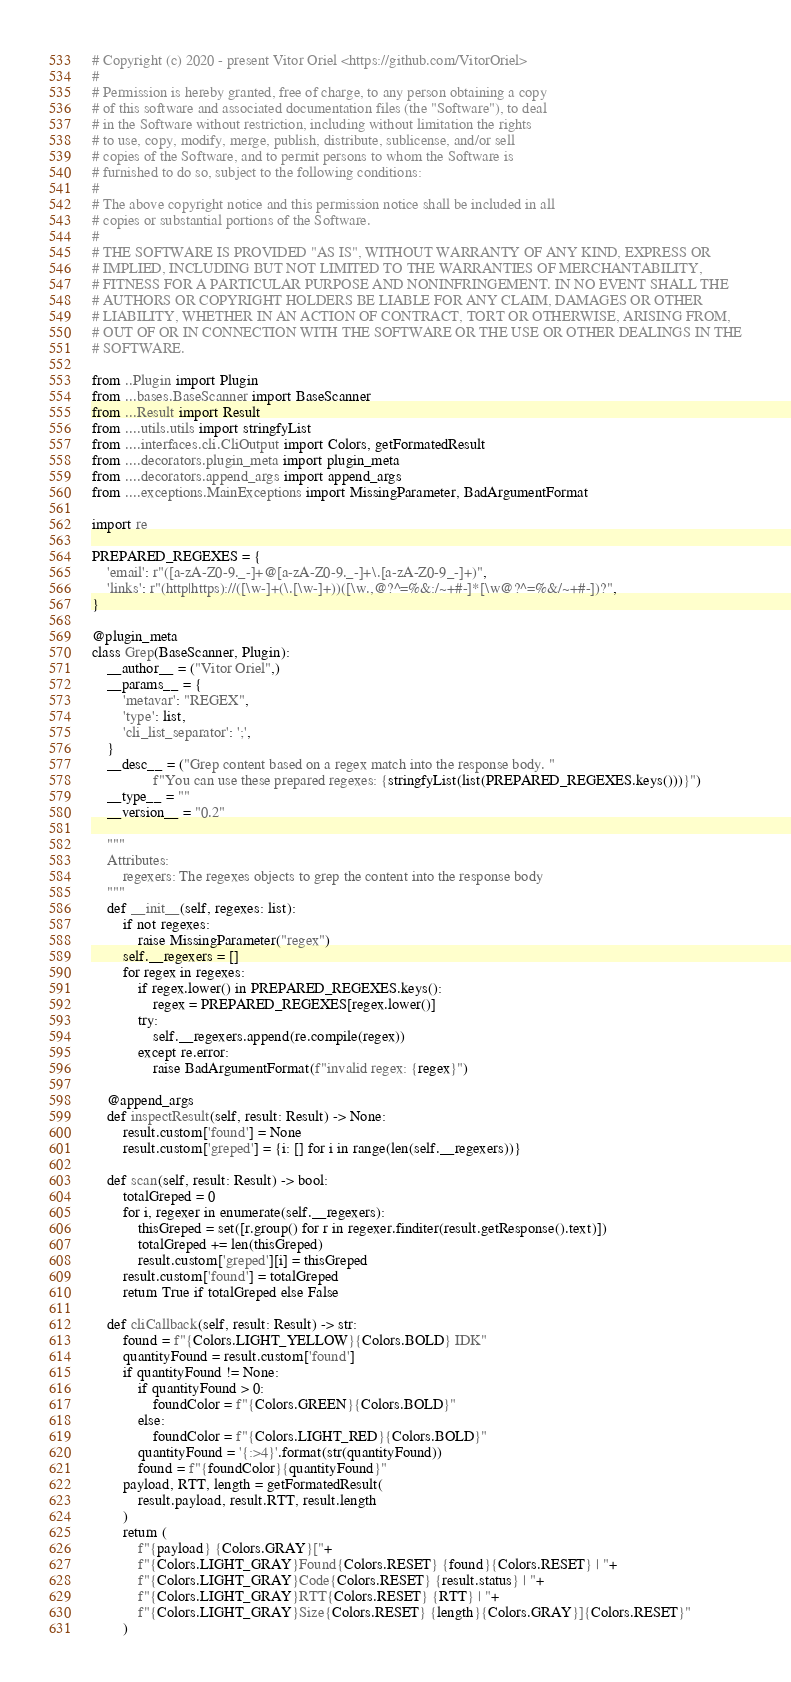<code> <loc_0><loc_0><loc_500><loc_500><_Python_># Copyright (c) 2020 - present Vitor Oriel <https://github.com/VitorOriel>
#
# Permission is hereby granted, free of charge, to any person obtaining a copy
# of this software and associated documentation files (the "Software"), to deal
# in the Software without restriction, including without limitation the rights
# to use, copy, modify, merge, publish, distribute, sublicense, and/or sell
# copies of the Software, and to permit persons to whom the Software is
# furnished to do so, subject to the following conditions:
#
# The above copyright notice and this permission notice shall be included in all
# copies or substantial portions of the Software.
#
# THE SOFTWARE IS PROVIDED "AS IS", WITHOUT WARRANTY OF ANY KIND, EXPRESS OR
# IMPLIED, INCLUDING BUT NOT LIMITED TO THE WARRANTIES OF MERCHANTABILITY,
# FITNESS FOR A PARTICULAR PURPOSE AND NONINFRINGEMENT. IN NO EVENT SHALL THE
# AUTHORS OR COPYRIGHT HOLDERS BE LIABLE FOR ANY CLAIM, DAMAGES OR OTHER
# LIABILITY, WHETHER IN AN ACTION OF CONTRACT, TORT OR OTHERWISE, ARISING FROM,
# OUT OF OR IN CONNECTION WITH THE SOFTWARE OR THE USE OR OTHER DEALINGS IN THE
# SOFTWARE.

from ..Plugin import Plugin
from ...bases.BaseScanner import BaseScanner
from ...Result import Result
from ....utils.utils import stringfyList
from ....interfaces.cli.CliOutput import Colors, getFormatedResult
from ....decorators.plugin_meta import plugin_meta
from ....decorators.append_args import append_args
from ....exceptions.MainExceptions import MissingParameter, BadArgumentFormat

import re

PREPARED_REGEXES = {
    'email': r"([a-zA-Z0-9._-]+@[a-zA-Z0-9._-]+\.[a-zA-Z0-9_-]+)",
    'links': r"(http|https)://([\w-]+(\.[\w-]+))([\w.,@?^=%&:/~+#-]*[\w@?^=%&/~+#-])?",
}

@plugin_meta
class Grep(BaseScanner, Plugin):
    __author__ = ("Vitor Oriel",)
    __params__ = {
        'metavar': "REGEX",
        'type': list,
        'cli_list_separator': ';',
    }
    __desc__ = ("Grep content based on a regex match into the response body. "
                f"You can use these prepared regexes: {stringfyList(list(PREPARED_REGEXES.keys()))}")
    __type__ = ""
    __version__ = "0.2"

    """
    Attributes:
        regexers: The regexes objects to grep the content into the response body
    """
    def __init__(self, regexes: list):
        if not regexes:
            raise MissingParameter("regex")
        self.__regexers = []
        for regex in regexes:
            if regex.lower() in PREPARED_REGEXES.keys():
                regex = PREPARED_REGEXES[regex.lower()]
            try:
                self.__regexers.append(re.compile(regex))
            except re.error:
                raise BadArgumentFormat(f"invalid regex: {regex}")

    @append_args
    def inspectResult(self, result: Result) -> None:
        result.custom['found'] = None
        result.custom['greped'] = {i: [] for i in range(len(self.__regexers))}

    def scan(self, result: Result) -> bool:
        totalGreped = 0
        for i, regexer in enumerate(self.__regexers):
            thisGreped = set([r.group() for r in regexer.finditer(result.getResponse().text)])
            totalGreped += len(thisGreped)
            result.custom['greped'][i] = thisGreped
        result.custom['found'] = totalGreped
        return True if totalGreped else False
    
    def cliCallback(self, result: Result) -> str:
        found = f"{Colors.LIGHT_YELLOW}{Colors.BOLD} IDK"
        quantityFound = result.custom['found']
        if quantityFound != None:
            if quantityFound > 0:
                foundColor = f"{Colors.GREEN}{Colors.BOLD}"
            else:
                foundColor = f"{Colors.LIGHT_RED}{Colors.BOLD}"
            quantityFound = '{:>4}'.format(str(quantityFound))
            found = f"{foundColor}{quantityFound}"
        payload, RTT, length = getFormatedResult(
            result.payload, result.RTT, result.length
        )
        return (
            f"{payload} {Colors.GRAY}["+
            f"{Colors.LIGHT_GRAY}Found{Colors.RESET} {found}{Colors.RESET} | "+
            f"{Colors.LIGHT_GRAY}Code{Colors.RESET} {result.status} | "+
            f"{Colors.LIGHT_GRAY}RTT{Colors.RESET} {RTT} | "+
            f"{Colors.LIGHT_GRAY}Size{Colors.RESET} {length}{Colors.GRAY}]{Colors.RESET}"
        )</code> 